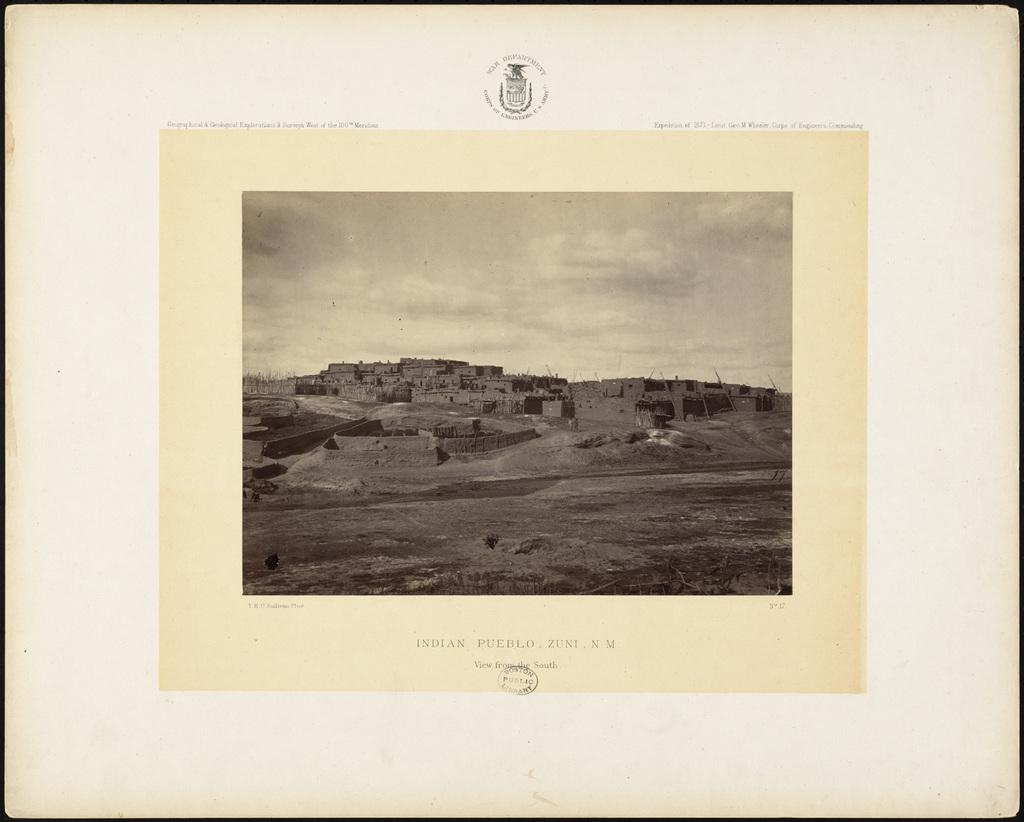Provide a one-sentence caption for the provided image. a picture with the name Indian pueblo on it. 